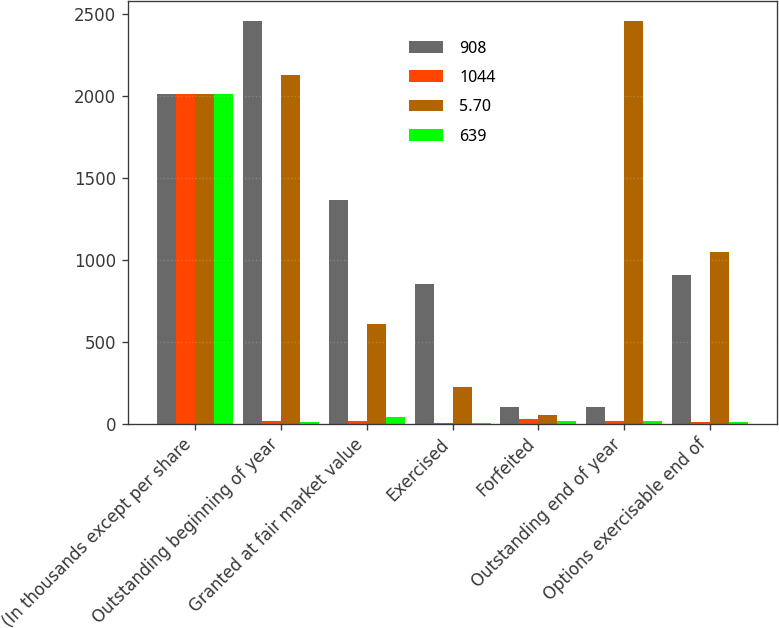<chart> <loc_0><loc_0><loc_500><loc_500><stacked_bar_chart><ecel><fcel>(In thousands except per share<fcel>Outstanding beginning of year<fcel>Granted at fair market value<fcel>Exercised<fcel>Forfeited<fcel>Outstanding end of year<fcel>Options exercisable end of<nl><fcel>908<fcel>2009<fcel>2456<fcel>1364<fcel>853<fcel>102<fcel>102<fcel>908<nl><fcel>1044<fcel>2009<fcel>15.92<fcel>14.53<fcel>4.69<fcel>27.04<fcel>18.02<fcel>11.58<nl><fcel>5.7<fcel>2008<fcel>2126<fcel>609<fcel>225<fcel>54<fcel>2456<fcel>1044<nl><fcel>639<fcel>2008<fcel>8.23<fcel>37.96<fcel>3.49<fcel>13.67<fcel>15.92<fcel>7.22<nl></chart> 